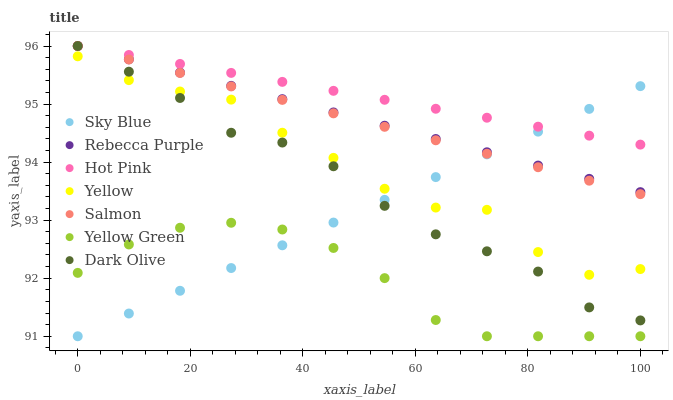Does Yellow Green have the minimum area under the curve?
Answer yes or no. Yes. Does Hot Pink have the maximum area under the curve?
Answer yes or no. Yes. Does Hot Pink have the minimum area under the curve?
Answer yes or no. No. Does Yellow Green have the maximum area under the curve?
Answer yes or no. No. Is Salmon the smoothest?
Answer yes or no. Yes. Is Yellow the roughest?
Answer yes or no. Yes. Is Yellow Green the smoothest?
Answer yes or no. No. Is Yellow Green the roughest?
Answer yes or no. No. Does Yellow Green have the lowest value?
Answer yes or no. Yes. Does Hot Pink have the lowest value?
Answer yes or no. No. Does Rebecca Purple have the highest value?
Answer yes or no. Yes. Does Yellow Green have the highest value?
Answer yes or no. No. Is Yellow Green less than Hot Pink?
Answer yes or no. Yes. Is Rebecca Purple greater than Yellow?
Answer yes or no. Yes. Does Sky Blue intersect Dark Olive?
Answer yes or no. Yes. Is Sky Blue less than Dark Olive?
Answer yes or no. No. Is Sky Blue greater than Dark Olive?
Answer yes or no. No. Does Yellow Green intersect Hot Pink?
Answer yes or no. No. 